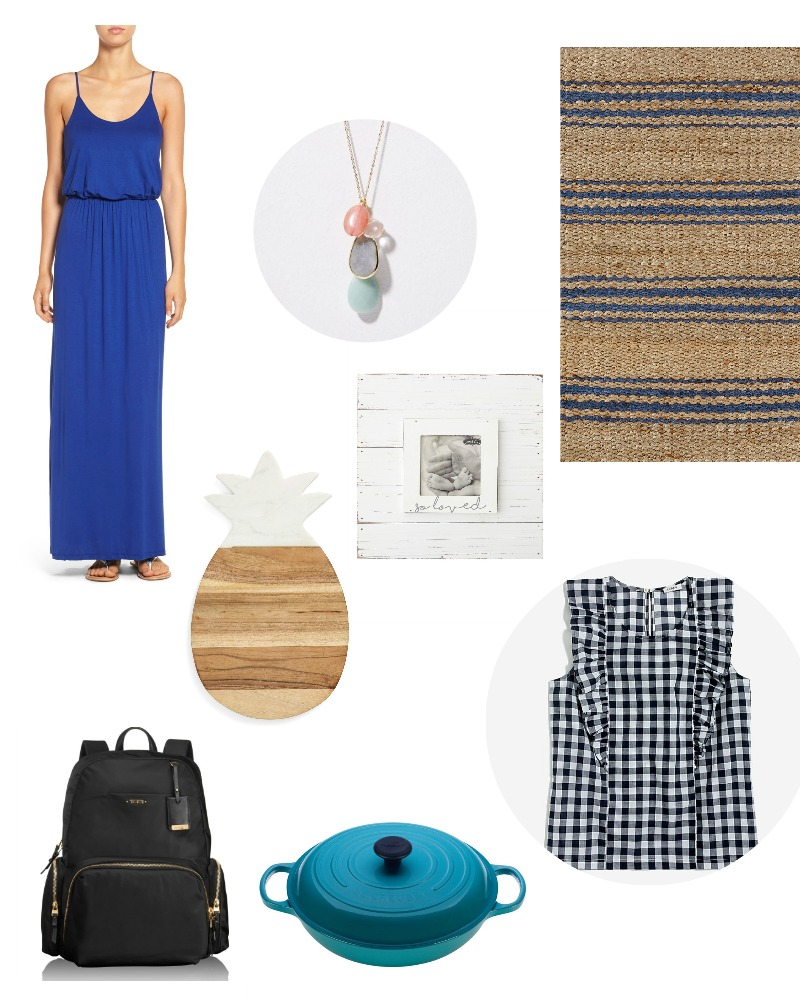Imagine you have to use these items to plan an unforgettable family picnic. How would you utilize each item? Planning an unforgettable family picnic with these items would be both fun and creative! Here’s how you could use each one to enhance the experience: 

Start by laying out the jute rug in a beautifully shaded area of the park. This rug offers a comfortable and natural space for everyone to sit and relax.

Clara could wear the elegant blue dress, making her the charming hostess of the picnic, while Jane sports the checkered top, giving the picnic a light and playful summer vibe.

The wooden pineapple cutting board would serve as a versatile tool. Use it to slice fruits and cheese, making a delightful and visually appealing platter for everyone to enjoy. The necklace, with its colorful stones, could be used as a playful adornment, perhaps as a treasure item in a game for kids.

Bring along the teal cast iron pot filled with Clara’s famous stew or perhaps a cold summer soup; it will stay warm and ready to serve whenever everyone’s ready for a delicious meal.

The black backpack can be used to carry picnic essentials – utensils, napkins, sunscreen, and maybe a book or two for some leisurely reading amidst nature.

Lastly, don’t forget the framed black and white photo. Use it as a centerpiece to evoke warm family memories and encourage storytelling sessions among the family members, making the picnic even more special and intimate. 

All these elements combined would not just create a practical picnic setup but also an atmosphere filled with comfort, style, and sentimental value, ensuring an unforgettable day for the entire family. If these items were elements in a fantastical world, what roles would they play? In a fantastical world, these items would take on enchanted roles with magical properties:

The blue dress would be a garment woven from the finest enchanted silk, granting the wearer not only elegance but also the power to become invisible at will, perfect for stealth and protection.

The necklace would be a powerful amulet, each stone representing a different element—Fire, Water, Earth, and Air—allowing its bearer to harness these elemental forces for various magical purposes.

The checkered top would belong to a master of disguise, transforming its appearance to blend with any environment, making its wearer a master of espionage.

The jute rug would be a magical carpet capable of flight, transporting those seated upon it to distant lands or hidden realms, guided by the holder’s thoughts and intentions.

The wooden pineapple cutting board would be an ancient artifact known as the Board of Abundance, where any food placed upon it multiplies, ensuring it never runs empty, a source of sustenance for those on a long journey.

The rustic photo frame would contain a portal to the past, allowing glimpses into forgotten times or lost memories, crucial in uncovering vital knowledge or secrets crucial to their quest.

The teal cast iron pot would be a Cauldron of Plenty, where any potion or stew brewed within it would have heightened effects, capable of healing wounds, granting strength, or even bestowing temporary magical abilities.

The black backpack with gold details would function as a Bag of Boundless Holding, infinitely expandable to carry treasures, weapons, and artifacts without ever becoming heavy or cumbersome.

In this enchanted realm, these items would aid heroes and adventurers on their epic quests, providing them with unique abilities, essential resources, and profound wisdom as they journey through mystical lands. 